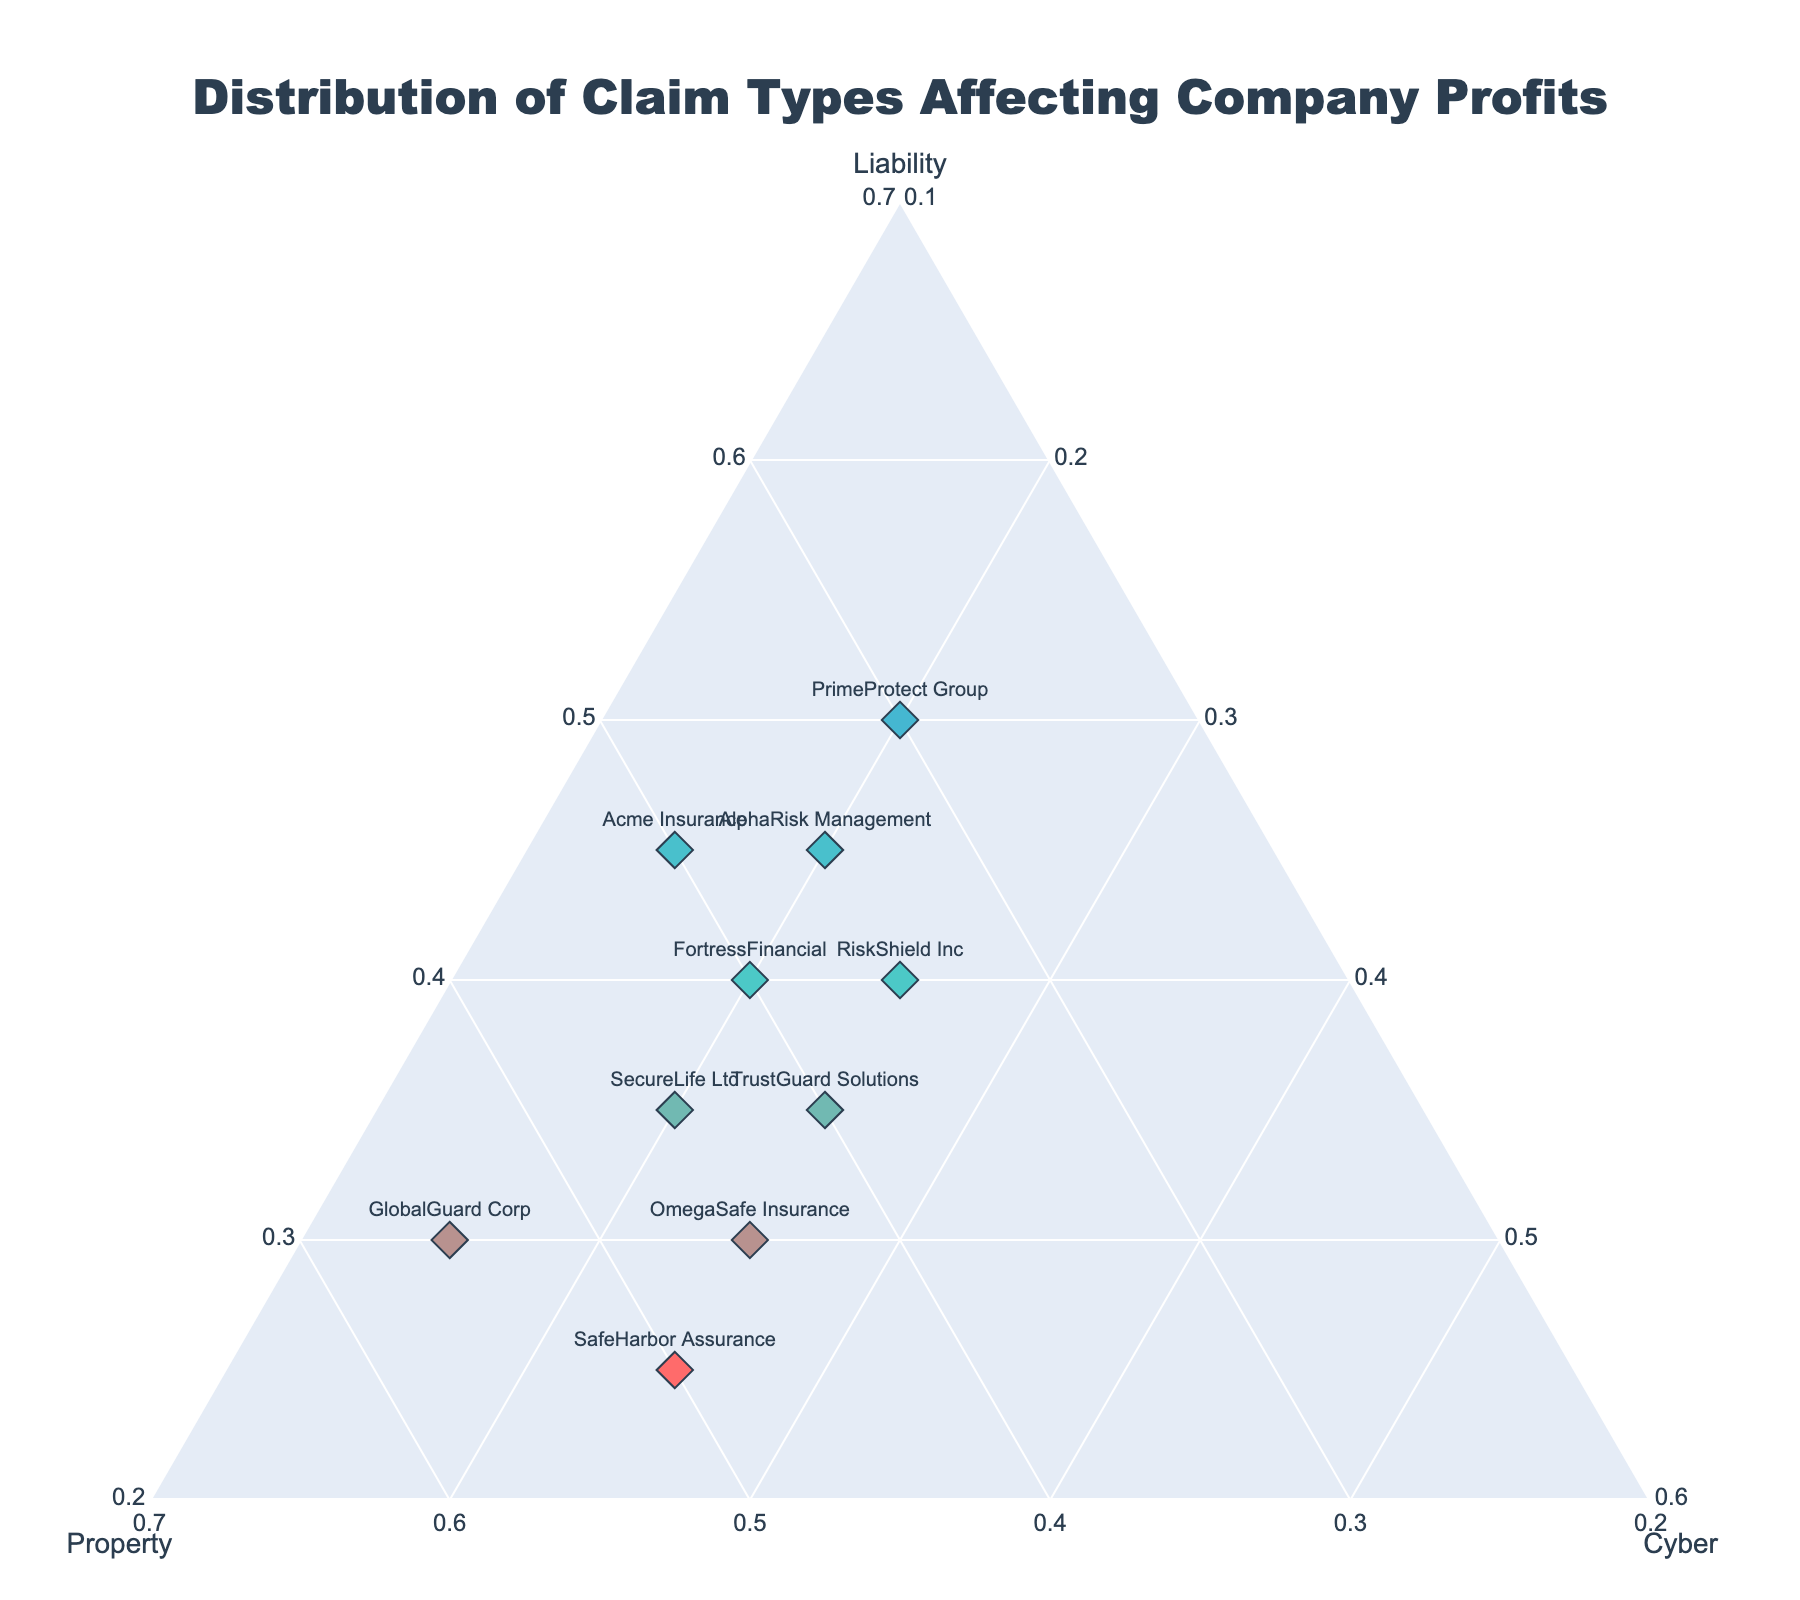What are the three types of claims represented in the plot? The plot displays the distribution of three types of claims affecting company profits. These claim types are represented as the axes in the ternary plot.
Answer: Liability, Property, Cyber Which company has the highest proportion of liability claims? Acme Insurance is plotted closest to the bottom axis (where liability values are highest), indicating it has the highest proportion of liability claims among the companies shown.
Answer: Acme Insurance How does RiskShield Inc compare to SafeHarbor Assurance in terms of cyber claims? RiskShield Inc has a cyber claim proportion of 0.25, and SafeHarbor Assurance also has a proportion of 0.25, so both companies have the same proportion of cyber claims.
Answer: Equal Which company has the most balanced claim distribution among liability, property, and cyber claims? FortressFinancial appears closest to the center of the ternary plot, indicating a relatively balanced distribution among the three claim types.
Answer: FortressFinancial What is the combined proportion of liability and property claims for PrimeProtect Group? PrimeProtect Group has a liability proportion of 0.50 and a property proportion of 0.30. Summing these gives 0.50 + 0.30.
Answer: 0.80 Identify the company with the highest proportion of property claims. By looking at the data points, GlobalGuard Corp is plotted closest to the bottom-left axis, indicating it has the highest proportion of property claims at 0.55.
Answer: GlobalGuard Corp Which company has the second highest proportion of cyber claims? RiskShield Inc has the highest proportion of cyber claims at 0.25, followed by SafeHarbor Assurance and OmegaSafe Insurance, both with a proportion of 0.25. However, since there are no higher values, 0.25 is the second highest as well.
Answer: SafeHarbor Assurance and OmegaSafe Insurance What would be the approximate average proportion of liability claims across all companies? Adding all liability proportions: 0.45 + 0.30 + 0.35 + 0.40 + 0.25 + 0.50 + 0.35 + 0.45 + 0.30 + 0.40 = 3.75. The average is calculated as 3.75 / 10.
Answer: 0.375 Which two companies have the same distribution of claim types? Looking at the data, SecureLife Ltd and GlobalGuard Corp have the liability, property, and cyber proportions as 0.35, 0.45, 0.20 and 0.30, 0.55, 0.15 respectively. Only RiskShield Inc and OmegaSafe Insurance both show 0.40, 0.35, and 0.25.
Answer: None How does TrustGuard Solutions compare to PrimeProtect Group in terms of liability and cyber claims? TrustGuard Solutions has a liability proportion of 0.35 and a cyber proportion of 0.25. PrimeProtect Group has a liability proportion of 0.50 and a cyber proportion of 0.20. TrustGuard Solutions has lower liability but higher cyber claims compared to PrimeProtect Group.
Answer: TrustGuard Solutions has lower liability but higher cyber claims 